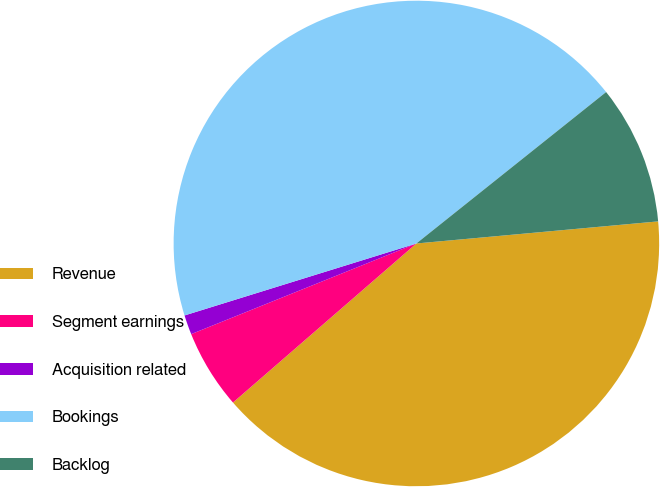Convert chart. <chart><loc_0><loc_0><loc_500><loc_500><pie_chart><fcel>Revenue<fcel>Segment earnings<fcel>Acquisition related<fcel>Bookings<fcel>Backlog<nl><fcel>40.08%<fcel>5.28%<fcel>1.3%<fcel>44.07%<fcel>9.27%<nl></chart> 